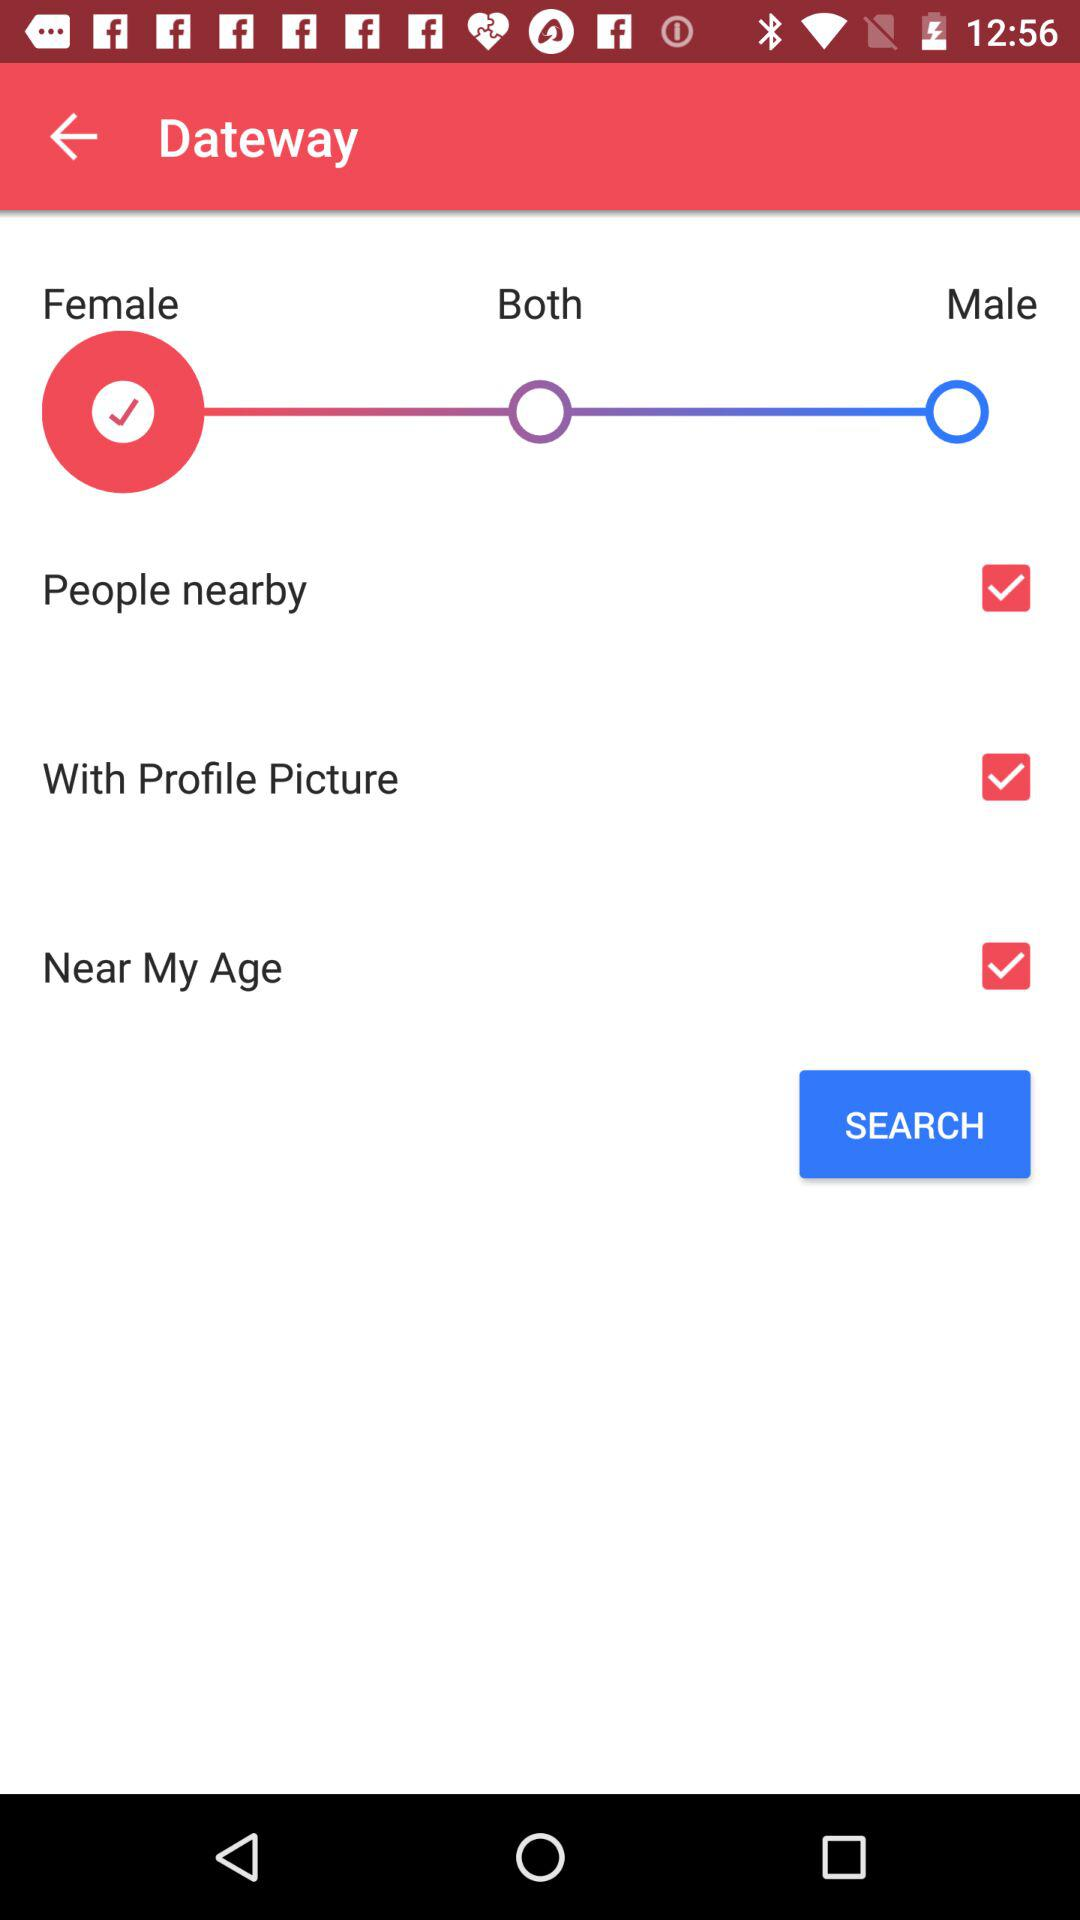What gender is opted? The opted gender is female. 